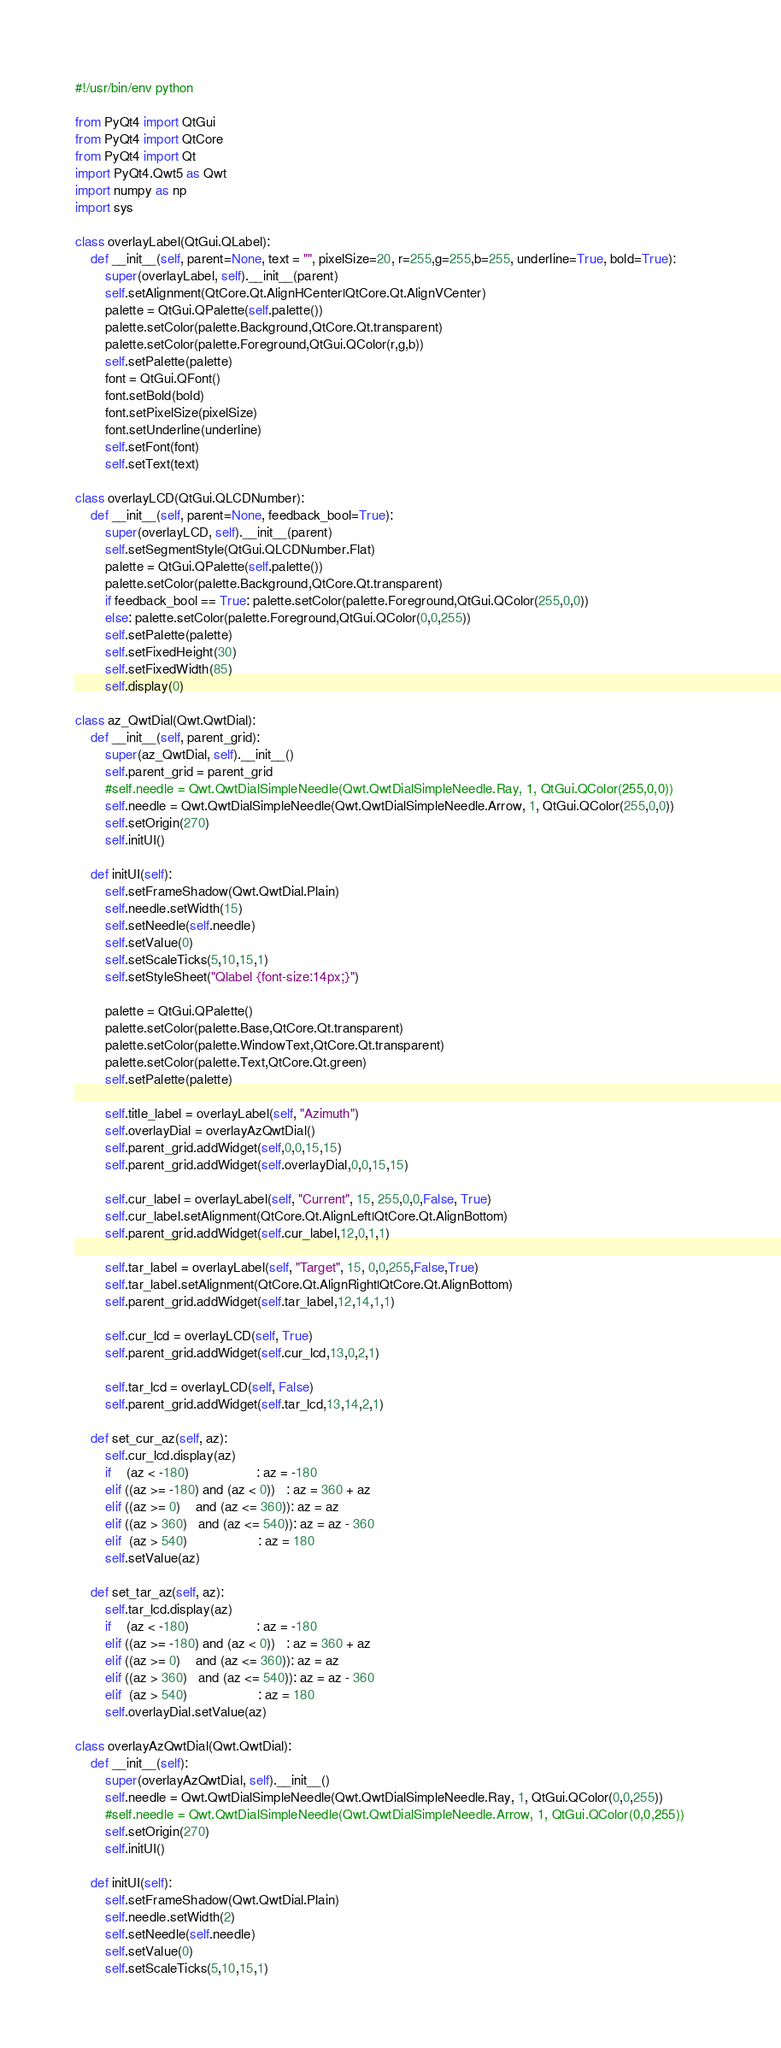Convert code to text. <code><loc_0><loc_0><loc_500><loc_500><_Python_>#!/usr/bin/env python

from PyQt4 import QtGui
from PyQt4 import QtCore
from PyQt4 import Qt
import PyQt4.Qwt5 as Qwt
import numpy as np
import sys

class overlayLabel(QtGui.QLabel):    
    def __init__(self, parent=None, text = "", pixelSize=20, r=255,g=255,b=255, underline=True, bold=True):        
        super(overlayLabel, self).__init__(parent)
        self.setAlignment(QtCore.Qt.AlignHCenter|QtCore.Qt.AlignVCenter)
        palette = QtGui.QPalette(self.palette())
        palette.setColor(palette.Background,QtCore.Qt.transparent)
        palette.setColor(palette.Foreground,QtGui.QColor(r,g,b))
        self.setPalette(palette)
        font = QtGui.QFont()
        font.setBold(bold)
        font.setPixelSize(pixelSize)
        font.setUnderline(underline)
        self.setFont(font)
        self.setText(text)

class overlayLCD(QtGui.QLCDNumber):    
    def __init__(self, parent=None, feedback_bool=True):        
        super(overlayLCD, self).__init__(parent)
        self.setSegmentStyle(QtGui.QLCDNumber.Flat)
        palette = QtGui.QPalette(self.palette())
        palette.setColor(palette.Background,QtCore.Qt.transparent)
        if feedback_bool == True: palette.setColor(palette.Foreground,QtGui.QColor(255,0,0))
        else: palette.setColor(palette.Foreground,QtGui.QColor(0,0,255))
        self.setPalette(palette)
        self.setFixedHeight(30)
        self.setFixedWidth(85)
        self.display(0)

class az_QwtDial(Qwt.QwtDial):
    def __init__(self, parent_grid):
        super(az_QwtDial, self).__init__()
        self.parent_grid = parent_grid
        #self.needle = Qwt.QwtDialSimpleNeedle(Qwt.QwtDialSimpleNeedle.Ray, 1, QtGui.QColor(255,0,0))
        self.needle = Qwt.QwtDialSimpleNeedle(Qwt.QwtDialSimpleNeedle.Arrow, 1, QtGui.QColor(255,0,0))
        self.setOrigin(270)
        self.initUI()

    def initUI(self):
        self.setFrameShadow(Qwt.QwtDial.Plain)
        self.needle.setWidth(15)
        self.setNeedle(self.needle)
        self.setValue(0)
        self.setScaleTicks(5,10,15,1)
        self.setStyleSheet("Qlabel {font-size:14px;}")

        palette = QtGui.QPalette()
        palette.setColor(palette.Base,QtCore.Qt.transparent)
        palette.setColor(palette.WindowText,QtCore.Qt.transparent)
        palette.setColor(palette.Text,QtCore.Qt.green)
        self.setPalette(palette)
        
        self.title_label = overlayLabel(self, "Azimuth")
        self.overlayDial = overlayAzQwtDial()
        self.parent_grid.addWidget(self,0,0,15,15)
        self.parent_grid.addWidget(self.overlayDial,0,0,15,15)

        self.cur_label = overlayLabel(self, "Current", 15, 255,0,0,False, True)
        self.cur_label.setAlignment(QtCore.Qt.AlignLeft|QtCore.Qt.AlignBottom)
        self.parent_grid.addWidget(self.cur_label,12,0,1,1)

        self.tar_label = overlayLabel(self, "Target", 15, 0,0,255,False,True)
        self.tar_label.setAlignment(QtCore.Qt.AlignRight|QtCore.Qt.AlignBottom)
        self.parent_grid.addWidget(self.tar_label,12,14,1,1)

        self.cur_lcd = overlayLCD(self, True)
        self.parent_grid.addWidget(self.cur_lcd,13,0,2,1)
        
        self.tar_lcd = overlayLCD(self, False)
        self.parent_grid.addWidget(self.tar_lcd,13,14,2,1)

    def set_cur_az(self, az):
        self.cur_lcd.display(az)
        if    (az < -180)                  : az = -180
        elif ((az >= -180) and (az < 0))   : az = 360 + az
        elif ((az >= 0)    and (az <= 360)): az = az
        elif ((az > 360)   and (az <= 540)): az = az - 360
        elif  (az > 540)                   : az = 180
        self.setValue(az)

    def set_tar_az(self, az):
        self.tar_lcd.display(az)
        if    (az < -180)                  : az = -180
        elif ((az >= -180) and (az < 0))   : az = 360 + az
        elif ((az >= 0)    and (az <= 360)): az = az
        elif ((az > 360)   and (az <= 540)): az = az - 360
        elif  (az > 540)                   : az = 180
        self.overlayDial.setValue(az)

class overlayAzQwtDial(Qwt.QwtDial):
    def __init__(self):
        super(overlayAzQwtDial, self).__init__()
        self.needle = Qwt.QwtDialSimpleNeedle(Qwt.QwtDialSimpleNeedle.Ray, 1, QtGui.QColor(0,0,255))
        #self.needle = Qwt.QwtDialSimpleNeedle(Qwt.QwtDialSimpleNeedle.Arrow, 1, QtGui.QColor(0,0,255))
        self.setOrigin(270)
        self.initUI()

    def initUI(self):
        self.setFrameShadow(Qwt.QwtDial.Plain)
        self.needle.setWidth(2)
        self.setNeedle(self.needle)
        self.setValue(0)
        self.setScaleTicks(5,10,15,1)</code> 